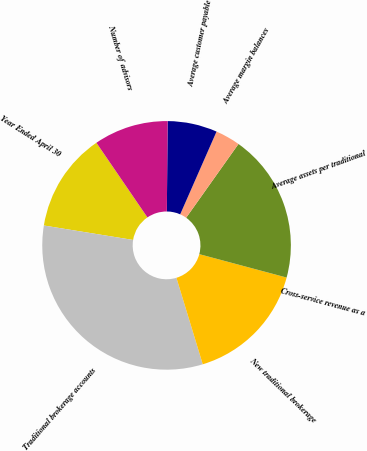<chart> <loc_0><loc_0><loc_500><loc_500><pie_chart><fcel>Year Ended April 30<fcel>Traditional brokerage accounts<fcel>New traditional brokerage<fcel>Cross-service revenue as a<fcel>Average assets per traditional<fcel>Average margin balances<fcel>Average customer payable<fcel>Number of advisors<nl><fcel>12.9%<fcel>32.26%<fcel>16.13%<fcel>0.0%<fcel>19.35%<fcel>3.23%<fcel>6.45%<fcel>9.68%<nl></chart> 